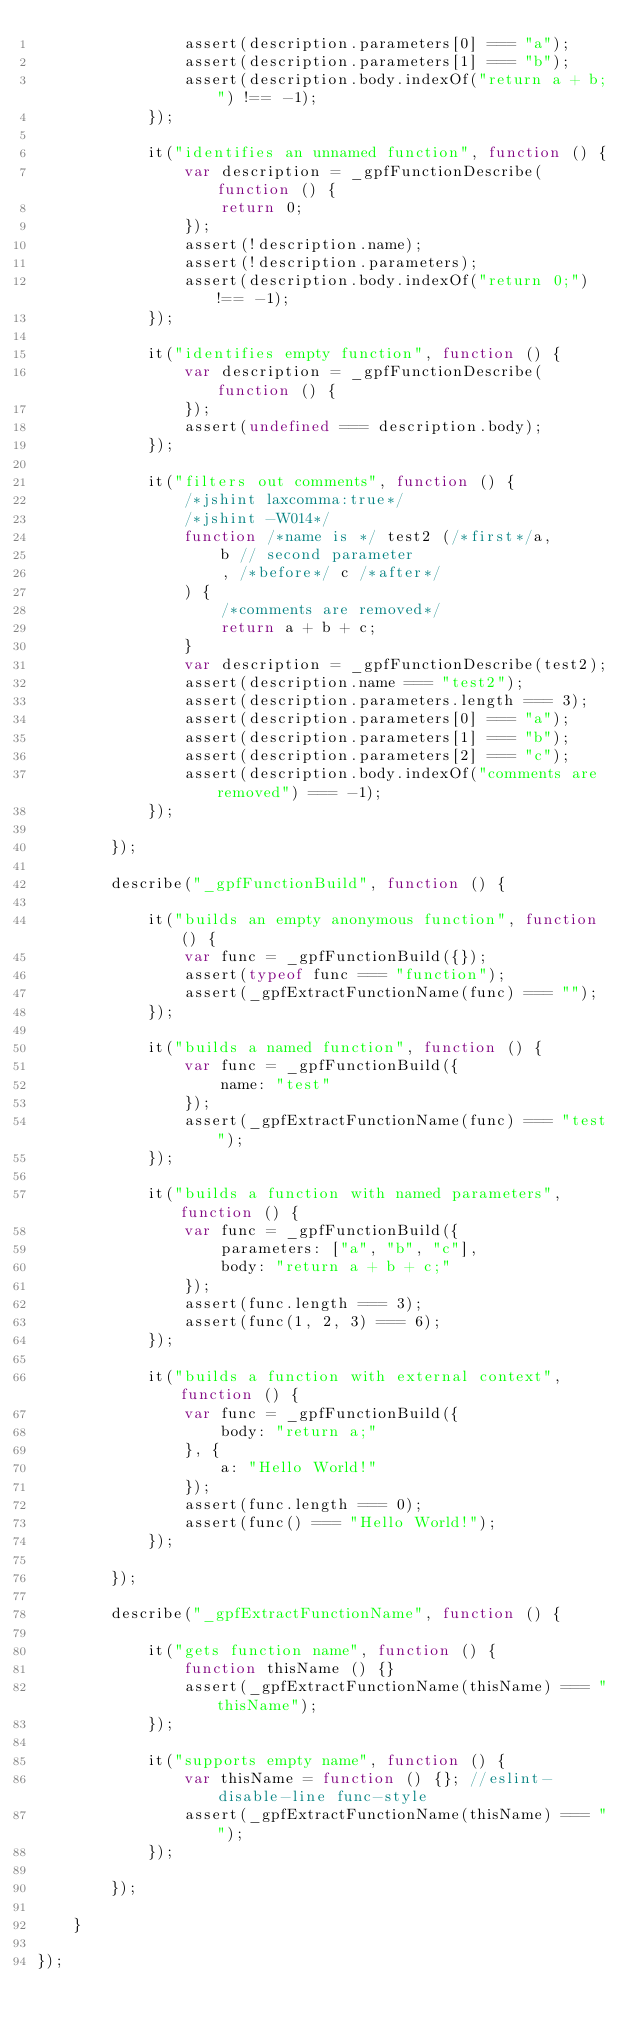Convert code to text. <code><loc_0><loc_0><loc_500><loc_500><_JavaScript_>                assert(description.parameters[0] === "a");
                assert(description.parameters[1] === "b");
                assert(description.body.indexOf("return a + b;") !== -1);
            });

            it("identifies an unnamed function", function () {
                var description = _gpfFunctionDescribe(function () {
                    return 0;
                });
                assert(!description.name);
                assert(!description.parameters);
                assert(description.body.indexOf("return 0;") !== -1);
            });

            it("identifies empty function", function () {
                var description = _gpfFunctionDescribe(function () {
                });
                assert(undefined === description.body);
            });

            it("filters out comments", function () {
                /*jshint laxcomma:true*/
                /*jshint -W014*/
                function /*name is */ test2 (/*first*/a,
                    b // second parameter
                    , /*before*/ c /*after*/
                ) {
                    /*comments are removed*/
                    return a + b + c;
                }
                var description = _gpfFunctionDescribe(test2);
                assert(description.name === "test2");
                assert(description.parameters.length === 3);
                assert(description.parameters[0] === "a");
                assert(description.parameters[1] === "b");
                assert(description.parameters[2] === "c");
                assert(description.body.indexOf("comments are removed") === -1);
            });

        });

        describe("_gpfFunctionBuild", function () {

            it("builds an empty anonymous function", function () {
                var func = _gpfFunctionBuild({});
                assert(typeof func === "function");
                assert(_gpfExtractFunctionName(func) === "");
            });

            it("builds a named function", function () {
                var func = _gpfFunctionBuild({
                    name: "test"
                });
                assert(_gpfExtractFunctionName(func) === "test");
            });

            it("builds a function with named parameters", function () {
                var func = _gpfFunctionBuild({
                    parameters: ["a", "b", "c"],
                    body: "return a + b + c;"
                });
                assert(func.length === 3);
                assert(func(1, 2, 3) === 6);
            });

            it("builds a function with external context", function () {
                var func = _gpfFunctionBuild({
                    body: "return a;"
                }, {
                    a: "Hello World!"
                });
                assert(func.length === 0);
                assert(func() === "Hello World!");
            });

        });

        describe("_gpfExtractFunctionName", function () {

            it("gets function name", function () {
                function thisName () {}
                assert(_gpfExtractFunctionName(thisName) === "thisName");
            });

            it("supports empty name", function () {
                var thisName = function () {}; //eslint-disable-line func-style
                assert(_gpfExtractFunctionName(thisName) === "");
            });

        });

    }

});
</code> 